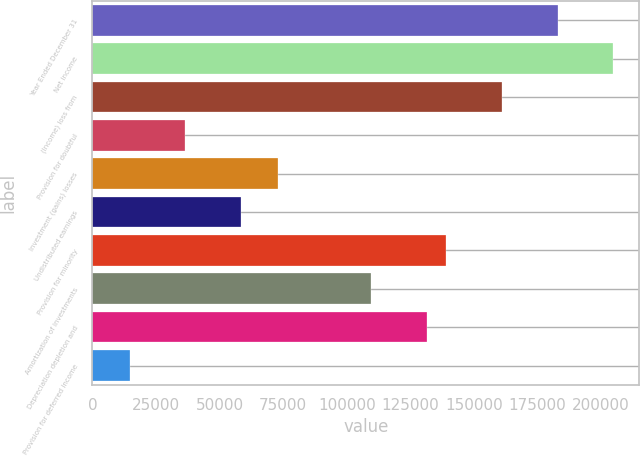Convert chart to OTSL. <chart><loc_0><loc_0><loc_500><loc_500><bar_chart><fcel>Year Ended December 31<fcel>Net income<fcel>(Income) loss from<fcel>Provision for doubtful<fcel>Investment (gains) losses<fcel>Undistributed earnings<fcel>Provision for minority<fcel>Amortization of investments<fcel>Depreciation depletion and<fcel>Provision for deferred income<nl><fcel>182891<fcel>204838<fcel>160944<fcel>36579<fcel>73157<fcel>58525.8<fcel>138997<fcel>109735<fcel>131682<fcel>14632.2<nl></chart> 